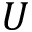<formula> <loc_0><loc_0><loc_500><loc_500>U</formula> 